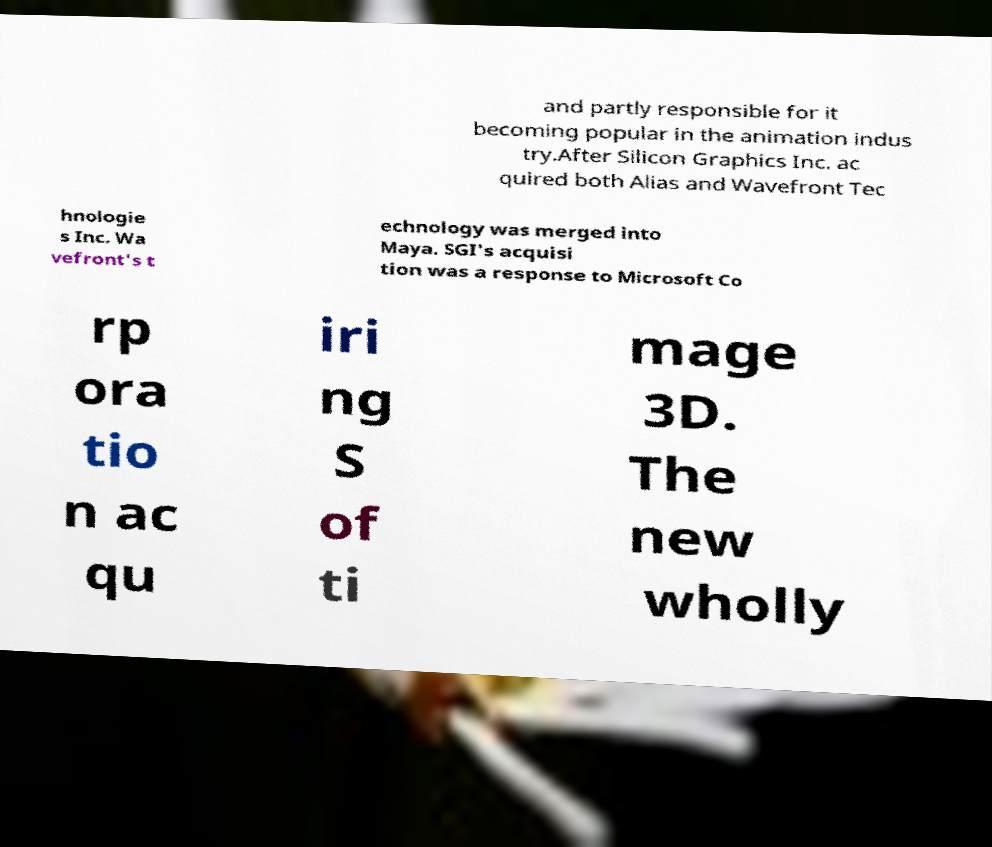Could you assist in decoding the text presented in this image and type it out clearly? and partly responsible for it becoming popular in the animation indus try.After Silicon Graphics Inc. ac quired both Alias and Wavefront Tec hnologie s Inc. Wa vefront's t echnology was merged into Maya. SGI's acquisi tion was a response to Microsoft Co rp ora tio n ac qu iri ng S of ti mage 3D. The new wholly 